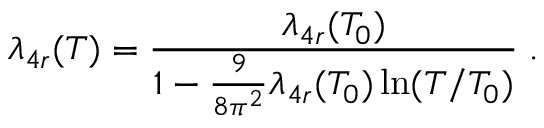Convert formula to latex. <formula><loc_0><loc_0><loc_500><loc_500>\lambda _ { 4 r } ( T ) = \frac { \lambda _ { 4 r } ( T _ { 0 } ) } { 1 - \frac { 9 } { 8 \pi ^ { 2 } } \lambda _ { 4 r } ( T _ { 0 } ) \ln ( T / T _ { 0 } ) } \, .</formula> 